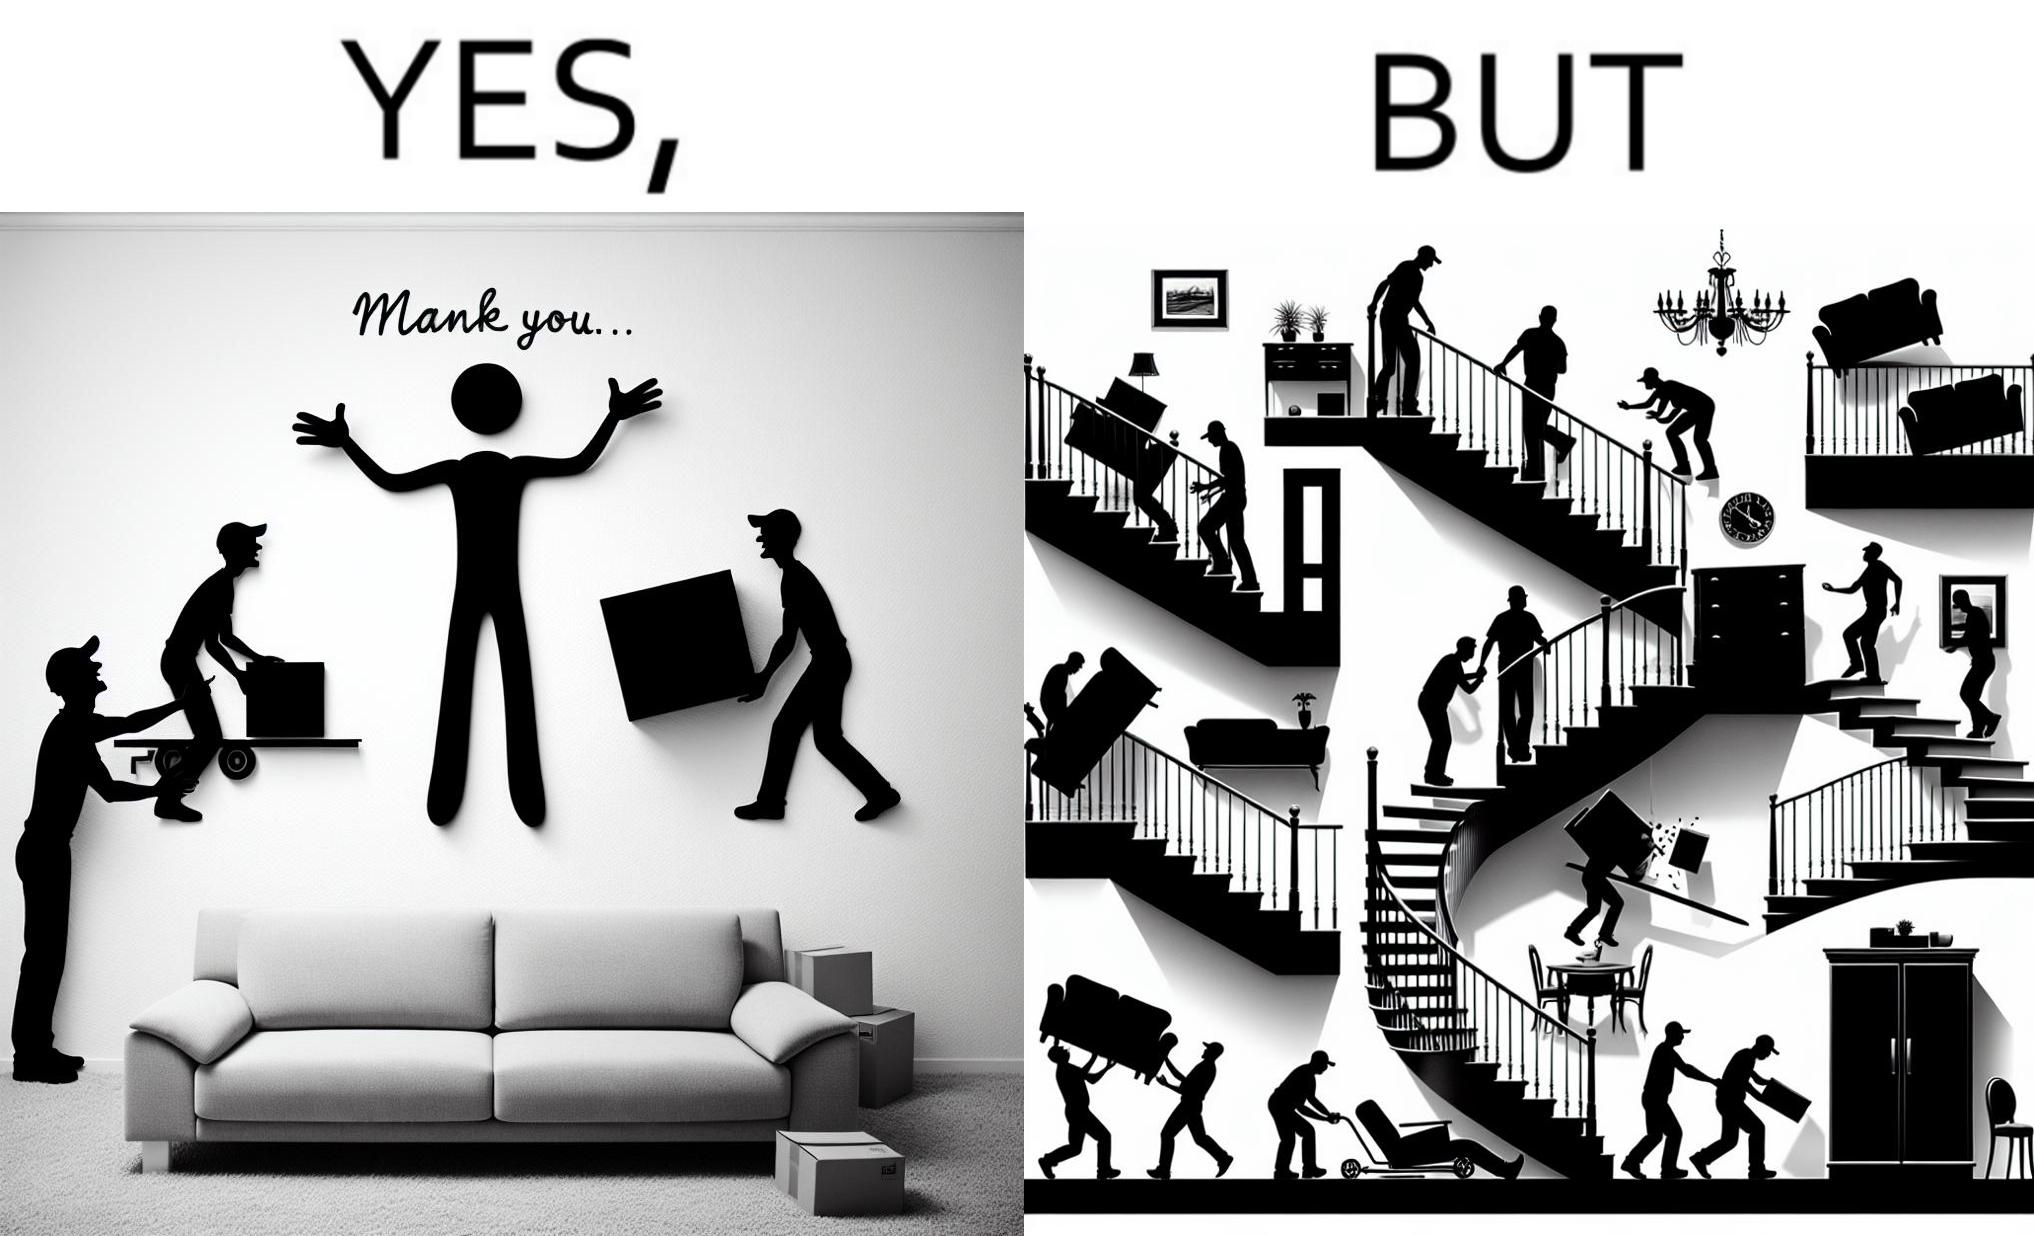Describe the content of this image. The images are funny since they show how even though the hired movers achieve their task of moving in furniture, in the process, the cause damage to the whole house 